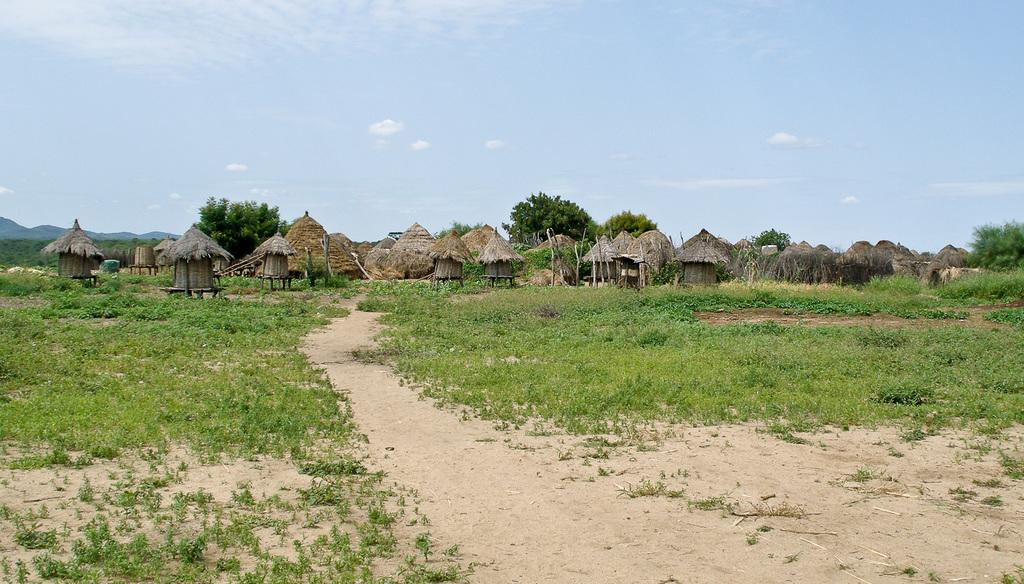What type of vegetation is present on the ground in the image? There are plants on the ground in the image. What other type of vegetation can be seen in the image? There are trees in the image. What structures are located in the middle of the image? There are huts in the middle of the image. What is visible in the background of the image? The sky is visible in the background of the image. What type of machine can be seen operating in the image? There is no machine present in the image. What is the reaction of the thumb in the image? There is no thumb present in the image, so it is not possible to determine any reaction. 